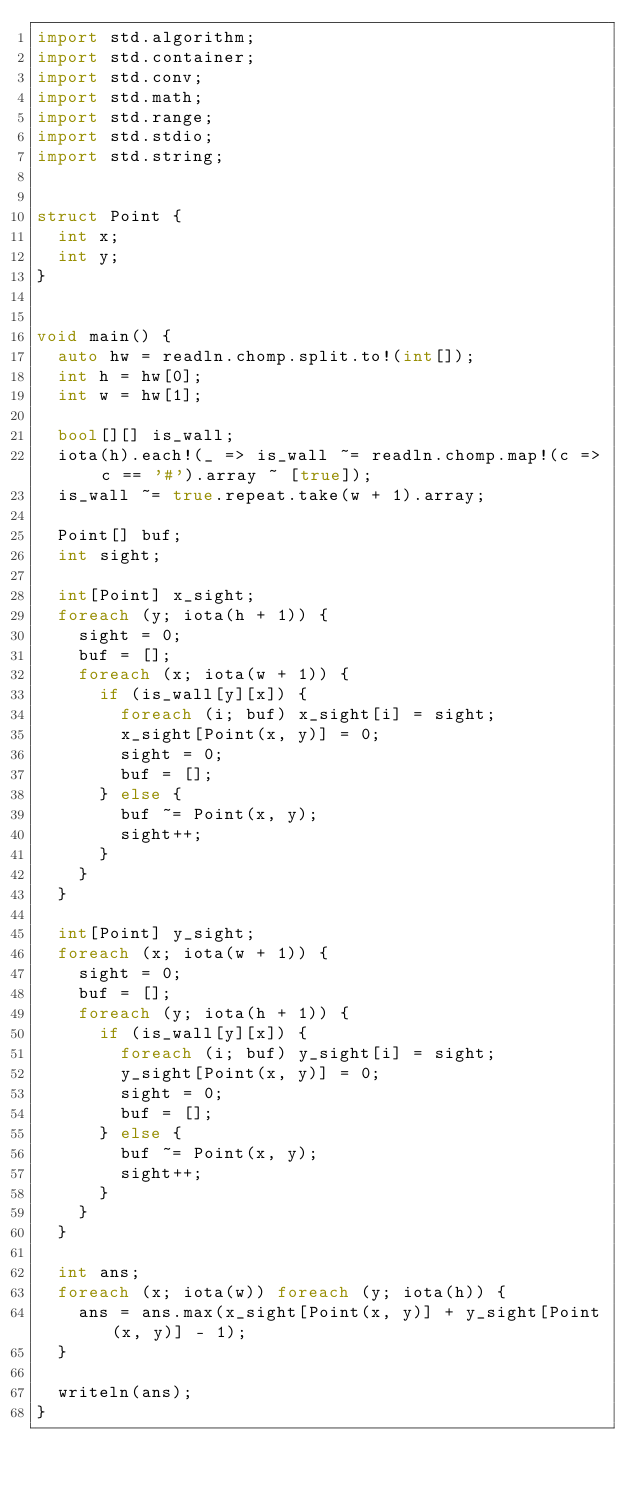Convert code to text. <code><loc_0><loc_0><loc_500><loc_500><_D_>import std.algorithm;
import std.container;
import std.conv;
import std.math;
import std.range;
import std.stdio;
import std.string;


struct Point {
  int x;
  int y;
}


void main() {
  auto hw = readln.chomp.split.to!(int[]);
  int h = hw[0];
  int w = hw[1];

  bool[][] is_wall;
  iota(h).each!(_ => is_wall ~= readln.chomp.map!(c => c == '#').array ~ [true]);
  is_wall ~= true.repeat.take(w + 1).array;

  Point[] buf;
  int sight;

  int[Point] x_sight;
  foreach (y; iota(h + 1)) {
    sight = 0;
    buf = [];
    foreach (x; iota(w + 1)) {
      if (is_wall[y][x]) {
        foreach (i; buf) x_sight[i] = sight;
        x_sight[Point(x, y)] = 0;
        sight = 0;
        buf = [];
      } else {
        buf ~= Point(x, y);
        sight++;
      }
    }
  }

  int[Point] y_sight;
  foreach (x; iota(w + 1)) {
    sight = 0;
    buf = [];
    foreach (y; iota(h + 1)) {
      if (is_wall[y][x]) {
        foreach (i; buf) y_sight[i] = sight;
        y_sight[Point(x, y)] = 0;
        sight = 0;
        buf = [];
      } else {
        buf ~= Point(x, y);
        sight++;
      }
    }
  }

  int ans;
  foreach (x; iota(w)) foreach (y; iota(h)) {
    ans = ans.max(x_sight[Point(x, y)] + y_sight[Point(x, y)] - 1);
  }

  writeln(ans);
}
</code> 